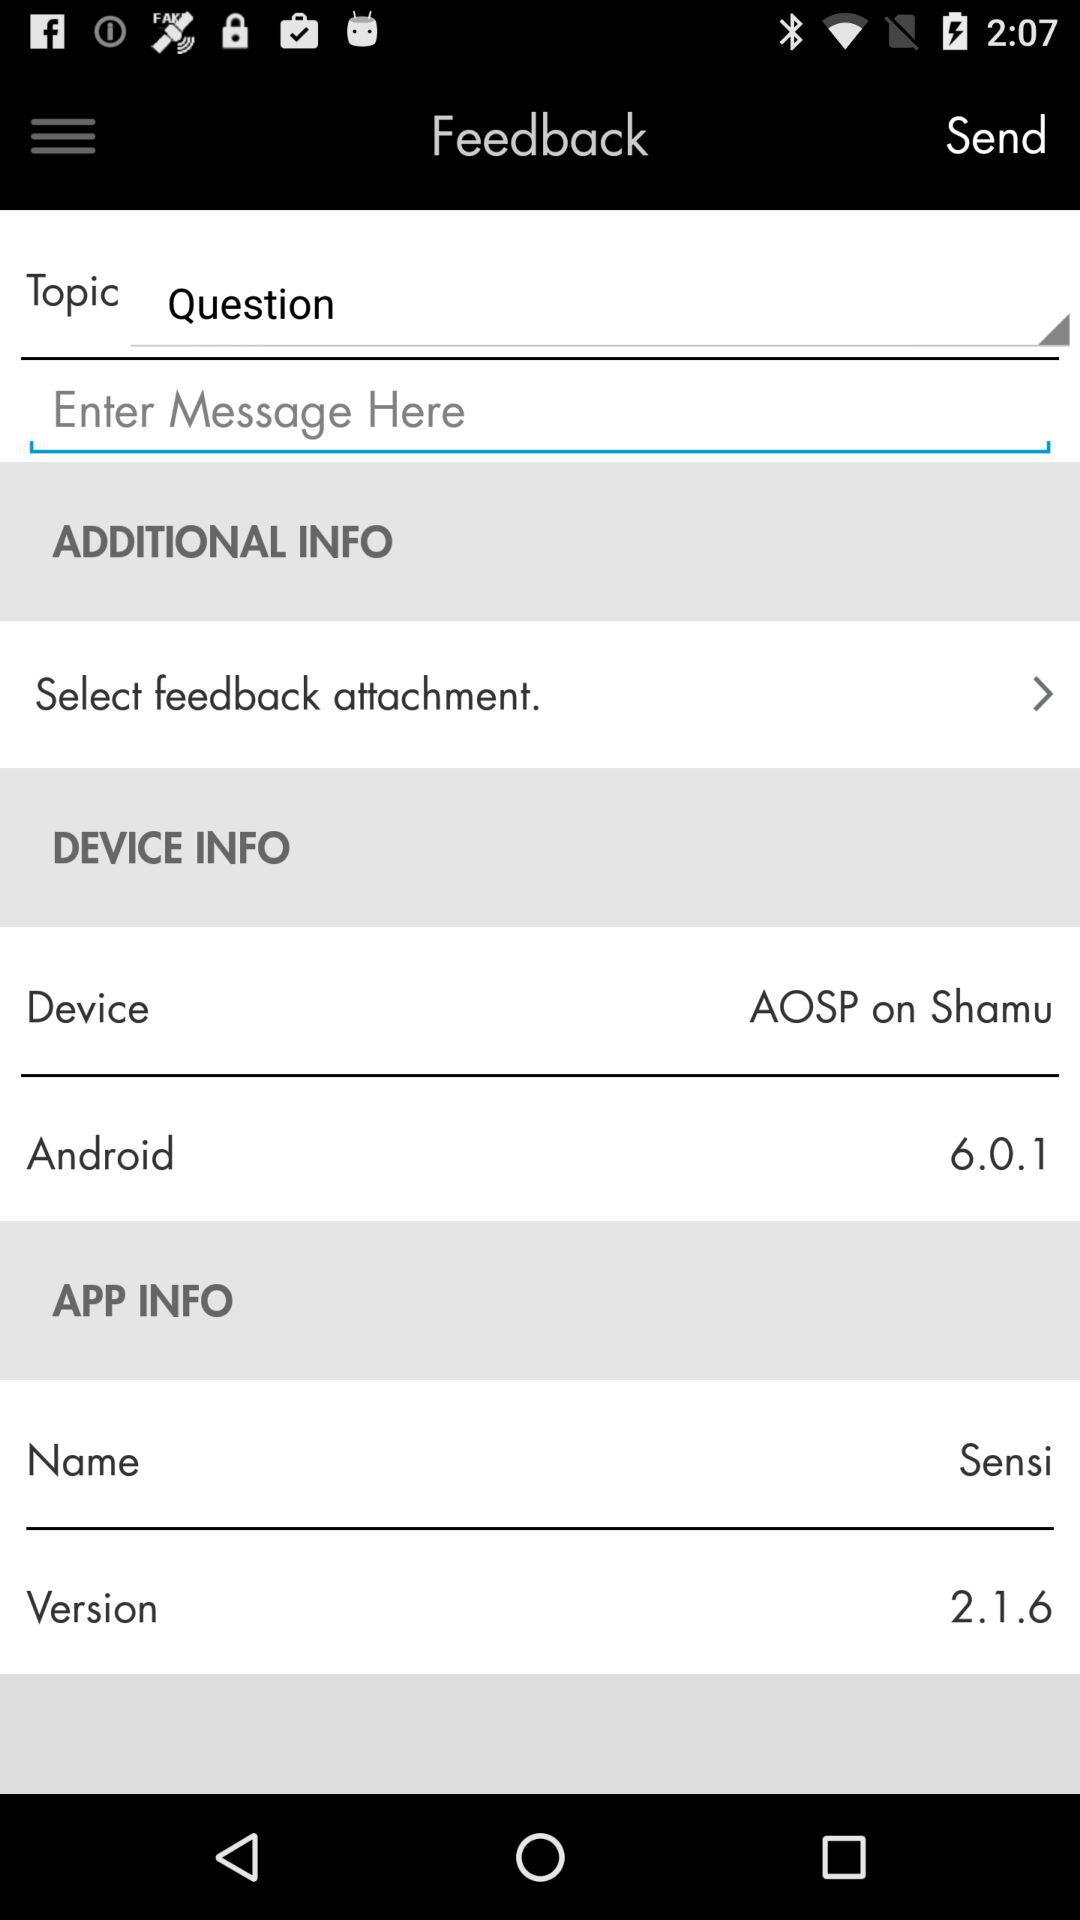What is the name of device? The name of the device is AOSP on Shamu. 